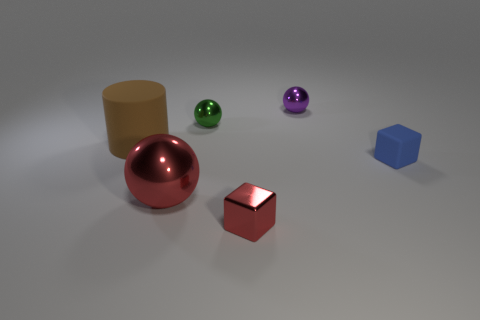Subtract all tiny metal balls. How many balls are left? 1 Add 2 green rubber cylinders. How many objects exist? 8 Subtract 1 cylinders. How many cylinders are left? 0 Subtract all red spheres. How many spheres are left? 2 Subtract 0 blue spheres. How many objects are left? 6 Subtract all cylinders. How many objects are left? 5 Subtract all brown spheres. Subtract all cyan cubes. How many spheres are left? 3 Subtract all green metal objects. Subtract all small purple metal spheres. How many objects are left? 4 Add 4 tiny purple metallic things. How many tiny purple metallic things are left? 5 Add 2 brown matte things. How many brown matte things exist? 3 